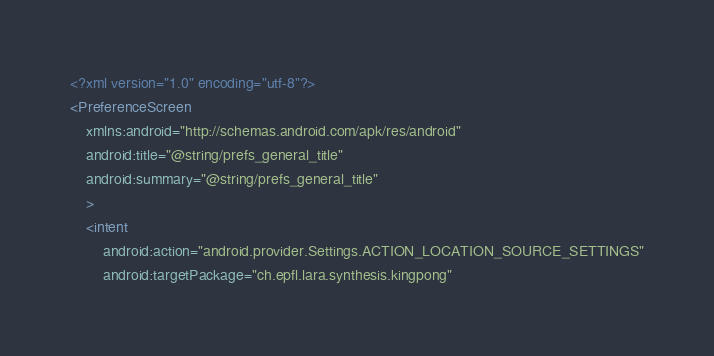<code> <loc_0><loc_0><loc_500><loc_500><_XML_><?xml version="1.0" encoding="utf-8"?>
<PreferenceScreen
    xmlns:android="http://schemas.android.com/apk/res/android"
    android:title="@string/prefs_general_title"
    android:summary="@string/prefs_general_title"
    >
    <intent
        android:action="android.provider.Settings.ACTION_LOCATION_SOURCE_SETTINGS"
        android:targetPackage="ch.epfl.lara.synthesis.kingpong"</code> 